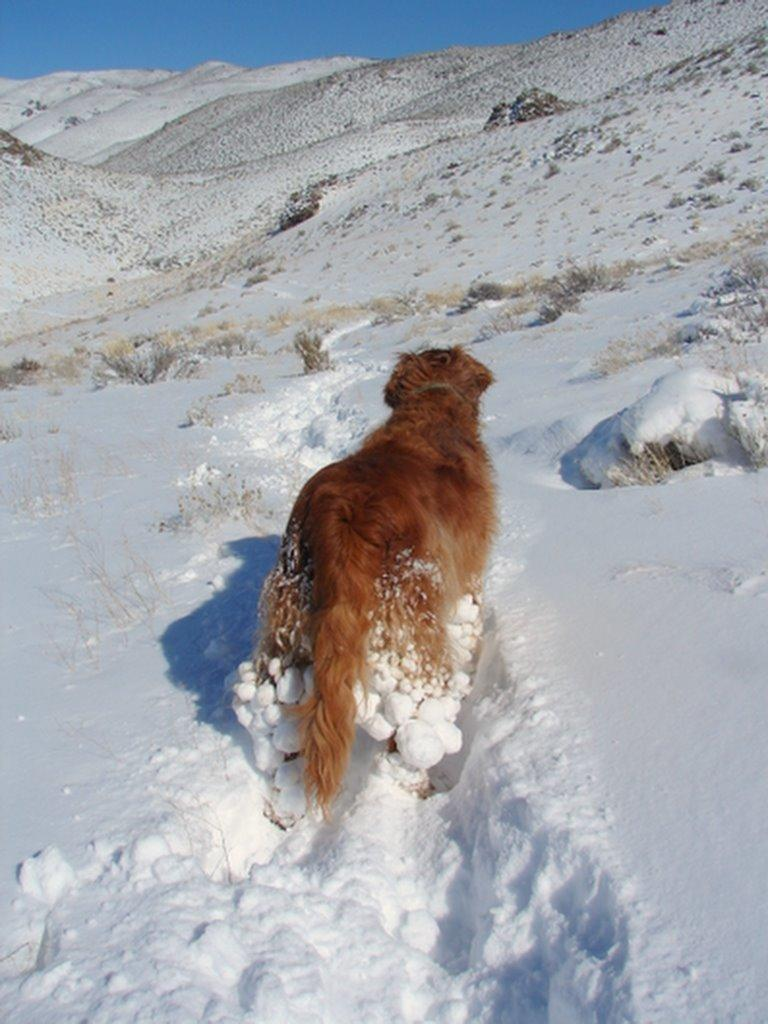What is the main subject of the image? The image depicts a mountain. Can you describe any living creatures in the image? There is an animal standing in the image. What type of vegetation can be seen in the image? Plants are visible in the image. What is visible at the top of the image? The sky is visible at the top of the image. What is the weather like at the bottom of the mountain? Snow is present at the bottom of the image, indicating a cold or snowy weather condition. What type of feast is being prepared at the top of the mountain in the image? There is no indication of a feast or any food preparation in the image; it primarily features a mountain, an animal, plants, and the sky. 